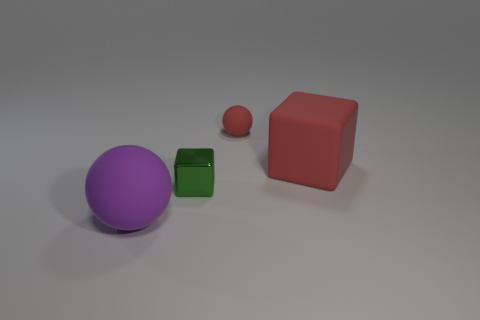Add 4 tiny matte balls. How many objects exist? 8 Subtract all yellow balls. How many green cubes are left? 1 Add 1 red matte objects. How many red matte objects are left? 3 Add 2 gray rubber spheres. How many gray rubber spheres exist? 2 Subtract 0 yellow cubes. How many objects are left? 4 Subtract all cyan balls. Subtract all cyan cubes. How many balls are left? 2 Subtract all large matte things. Subtract all big balls. How many objects are left? 1 